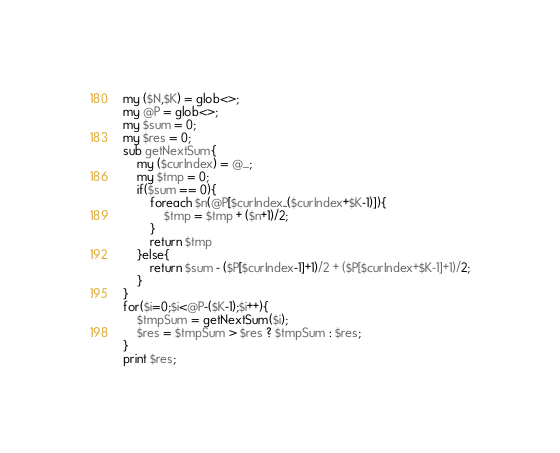<code> <loc_0><loc_0><loc_500><loc_500><_Perl_>my ($N,$K) = glob<>;
my @P = glob<>;
my $sum = 0;
my $res = 0;
sub getNextSum{
    my ($curIndex) = @_;
    my $tmp = 0;
    if($sum == 0){
        foreach $n(@P[$curIndex..($curIndex+$K-1)]){
            $tmp = $tmp + ($n+1)/2;
        }
        return $tmp
    }else{
        return $sum - ($P[$curIndex-1]+1)/2 + ($P[$curIndex+$K-1]+1)/2;
    }
}
for($i=0;$i<@P-($K-1);$i++){
    $tmpSum = getNextSum($i);
    $res = $tmpSum > $res ? $tmpSum : $res;
}
print $res;
</code> 